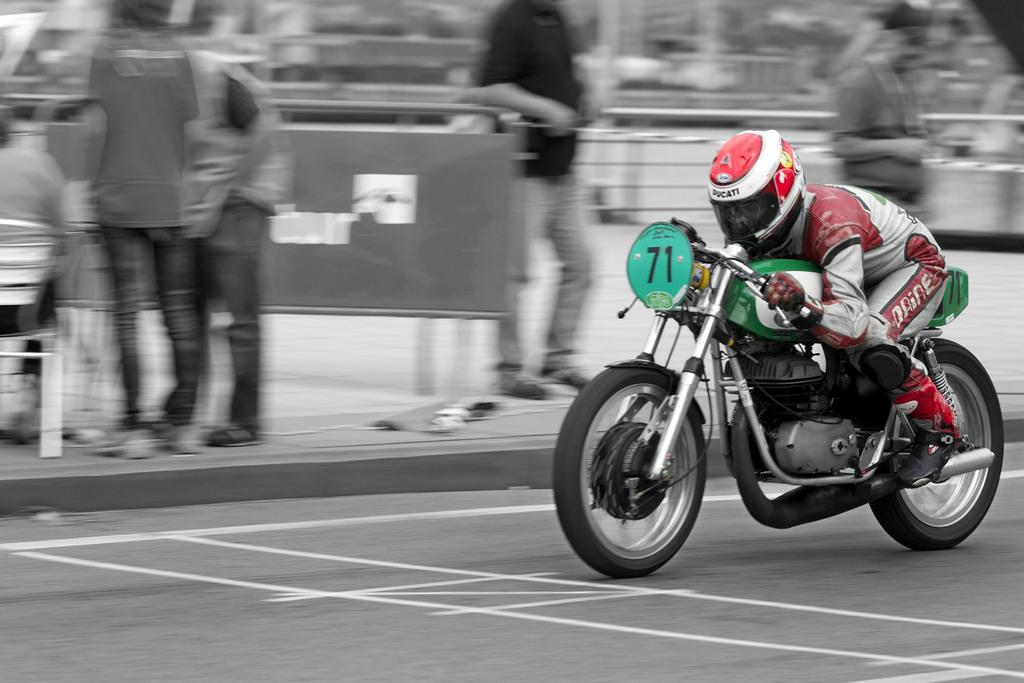What is the person doing in the image? The person is riding a vehicle on the road. Where is the vehicle located in the image? The vehicle is on the road. What can be seen on the side of the road? There are many persons standing on the footpath. What type of ball is being worn by the person riding the vehicle? There is no ball present in the image, and the person is not wearing any clothing that resembles a ball. 